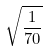<formula> <loc_0><loc_0><loc_500><loc_500>\sqrt { \frac { 1 } { 7 0 } }</formula> 